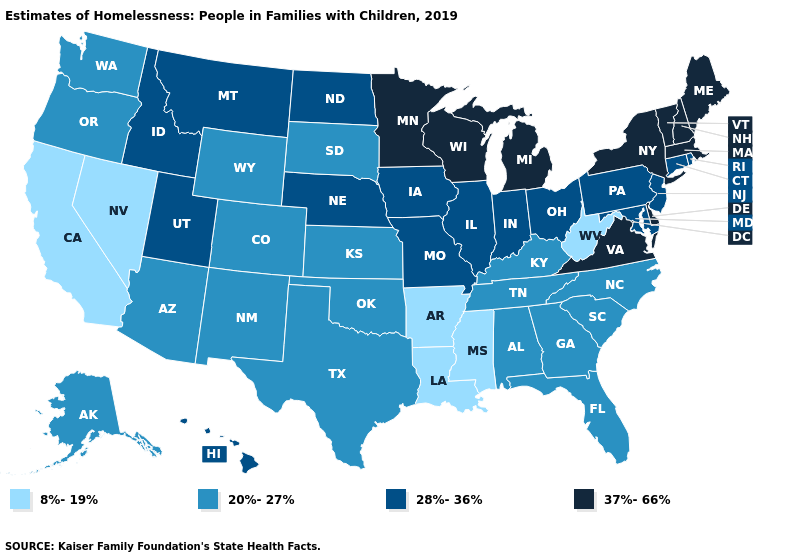Does West Virginia have the lowest value in the USA?
Answer briefly. Yes. Name the states that have a value in the range 37%-66%?
Short answer required. Delaware, Maine, Massachusetts, Michigan, Minnesota, New Hampshire, New York, Vermont, Virginia, Wisconsin. Name the states that have a value in the range 37%-66%?
Give a very brief answer. Delaware, Maine, Massachusetts, Michigan, Minnesota, New Hampshire, New York, Vermont, Virginia, Wisconsin. What is the lowest value in states that border Louisiana?
Answer briefly. 8%-19%. Which states have the highest value in the USA?
Quick response, please. Delaware, Maine, Massachusetts, Michigan, Minnesota, New Hampshire, New York, Vermont, Virginia, Wisconsin. What is the value of Illinois?
Answer briefly. 28%-36%. What is the value of Louisiana?
Give a very brief answer. 8%-19%. Name the states that have a value in the range 20%-27%?
Keep it brief. Alabama, Alaska, Arizona, Colorado, Florida, Georgia, Kansas, Kentucky, New Mexico, North Carolina, Oklahoma, Oregon, South Carolina, South Dakota, Tennessee, Texas, Washington, Wyoming. What is the value of Alabama?
Concise answer only. 20%-27%. What is the lowest value in states that border Wyoming?
Write a very short answer. 20%-27%. Name the states that have a value in the range 28%-36%?
Be succinct. Connecticut, Hawaii, Idaho, Illinois, Indiana, Iowa, Maryland, Missouri, Montana, Nebraska, New Jersey, North Dakota, Ohio, Pennsylvania, Rhode Island, Utah. Which states hav the highest value in the Northeast?
Write a very short answer. Maine, Massachusetts, New Hampshire, New York, Vermont. Does Ohio have a higher value than Hawaii?
Keep it brief. No. Which states hav the highest value in the South?
Short answer required. Delaware, Virginia. What is the value of North Carolina?
Be succinct. 20%-27%. 